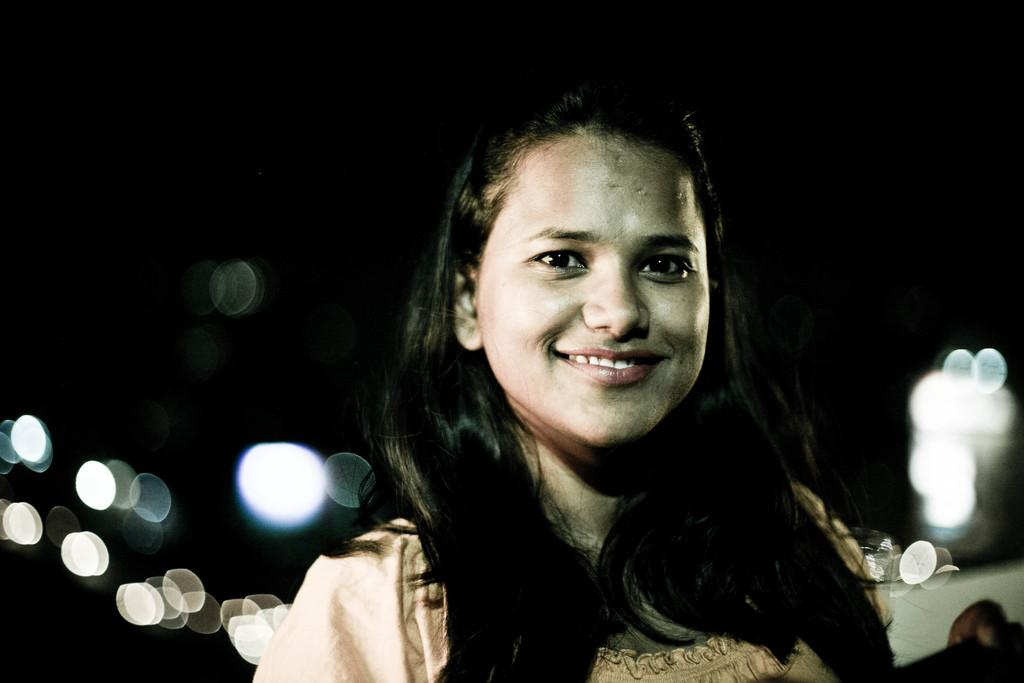Who or what is present on the right side of the image? There is a person on the right side of the image. What is the person doing or expressing in the image? The person is smiling in the image. What type of soup is the person holding in the image? There is no soup present in the image; the person is simply smiling. 